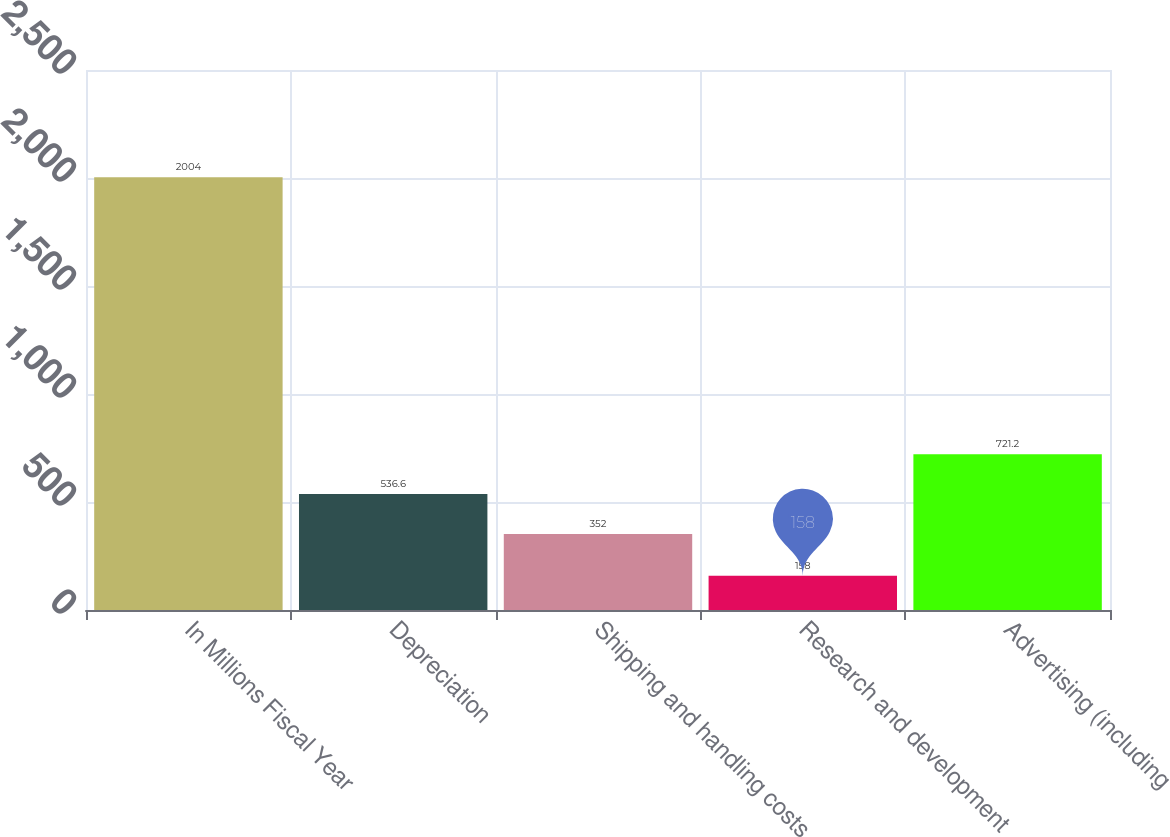<chart> <loc_0><loc_0><loc_500><loc_500><bar_chart><fcel>In Millions Fiscal Year<fcel>Depreciation<fcel>Shipping and handling costs<fcel>Research and development<fcel>Advertising (including<nl><fcel>2004<fcel>536.6<fcel>352<fcel>158<fcel>721.2<nl></chart> 